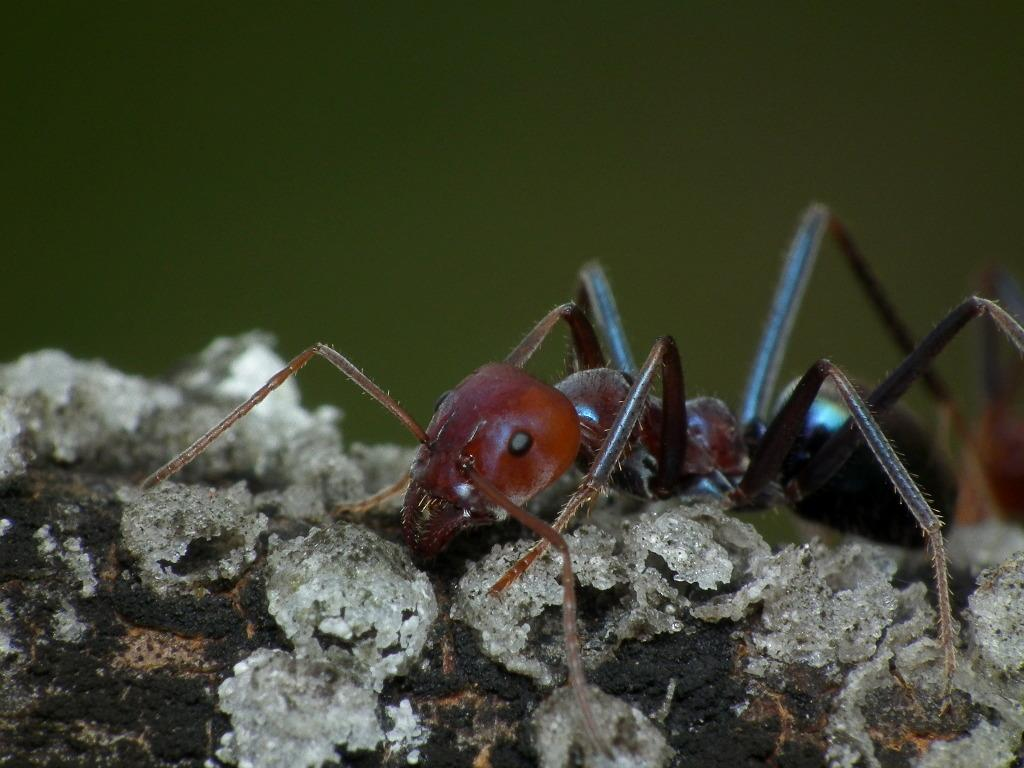What type of creature can be seen in the image? There is an insect in the image. Where is the insect located? The insect is on a wooden block. What type of road is visible in the image? There is no road visible in the image; it only features an insect on a wooden block. 